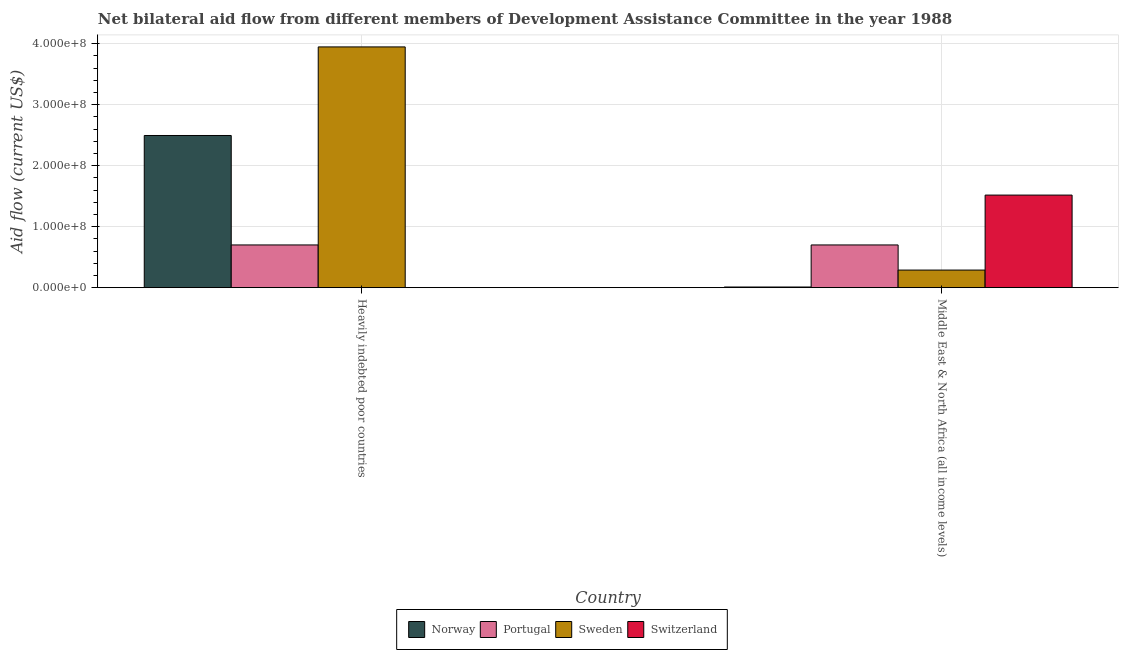Are the number of bars on each tick of the X-axis equal?
Your answer should be compact. Yes. How many bars are there on the 1st tick from the left?
Provide a short and direct response. 4. How many bars are there on the 1st tick from the right?
Give a very brief answer. 4. What is the label of the 1st group of bars from the left?
Your answer should be compact. Heavily indebted poor countries. In how many cases, is the number of bars for a given country not equal to the number of legend labels?
Your answer should be compact. 0. What is the amount of aid given by portugal in Heavily indebted poor countries?
Offer a terse response. 7.00e+07. Across all countries, what is the maximum amount of aid given by switzerland?
Provide a succinct answer. 1.52e+08. Across all countries, what is the minimum amount of aid given by switzerland?
Offer a terse response. 1.80e+05. In which country was the amount of aid given by norway maximum?
Ensure brevity in your answer.  Heavily indebted poor countries. In which country was the amount of aid given by sweden minimum?
Keep it short and to the point. Middle East & North Africa (all income levels). What is the total amount of aid given by norway in the graph?
Provide a succinct answer. 2.50e+08. What is the difference between the amount of aid given by norway in Heavily indebted poor countries and that in Middle East & North Africa (all income levels)?
Your response must be concise. 2.48e+08. What is the difference between the amount of aid given by norway in Heavily indebted poor countries and the amount of aid given by sweden in Middle East & North Africa (all income levels)?
Offer a terse response. 2.21e+08. What is the average amount of aid given by switzerland per country?
Make the answer very short. 7.60e+07. What is the difference between the amount of aid given by sweden and amount of aid given by switzerland in Heavily indebted poor countries?
Give a very brief answer. 3.94e+08. In how many countries, is the amount of aid given by norway greater than 20000000 US$?
Your answer should be very brief. 1. What is the ratio of the amount of aid given by sweden in Heavily indebted poor countries to that in Middle East & North Africa (all income levels)?
Provide a short and direct response. 13.68. Is the amount of aid given by sweden in Heavily indebted poor countries less than that in Middle East & North Africa (all income levels)?
Offer a very short reply. No. In how many countries, is the amount of aid given by switzerland greater than the average amount of aid given by switzerland taken over all countries?
Provide a succinct answer. 1. Is it the case that in every country, the sum of the amount of aid given by sweden and amount of aid given by portugal is greater than the sum of amount of aid given by norway and amount of aid given by switzerland?
Offer a very short reply. No. What does the 1st bar from the left in Heavily indebted poor countries represents?
Your response must be concise. Norway. What does the 3rd bar from the right in Heavily indebted poor countries represents?
Provide a succinct answer. Portugal. Is it the case that in every country, the sum of the amount of aid given by norway and amount of aid given by portugal is greater than the amount of aid given by sweden?
Offer a terse response. No. How many bars are there?
Ensure brevity in your answer.  8. What is the difference between two consecutive major ticks on the Y-axis?
Your response must be concise. 1.00e+08. Are the values on the major ticks of Y-axis written in scientific E-notation?
Your response must be concise. Yes. Does the graph contain grids?
Offer a terse response. Yes. Where does the legend appear in the graph?
Your response must be concise. Bottom center. What is the title of the graph?
Offer a very short reply. Net bilateral aid flow from different members of Development Assistance Committee in the year 1988. What is the Aid flow (current US$) in Norway in Heavily indebted poor countries?
Your answer should be very brief. 2.49e+08. What is the Aid flow (current US$) in Portugal in Heavily indebted poor countries?
Offer a very short reply. 7.00e+07. What is the Aid flow (current US$) in Sweden in Heavily indebted poor countries?
Your response must be concise. 3.95e+08. What is the Aid flow (current US$) in Switzerland in Heavily indebted poor countries?
Give a very brief answer. 1.80e+05. What is the Aid flow (current US$) in Norway in Middle East & North Africa (all income levels)?
Your response must be concise. 1.07e+06. What is the Aid flow (current US$) of Portugal in Middle East & North Africa (all income levels)?
Make the answer very short. 7.00e+07. What is the Aid flow (current US$) in Sweden in Middle East & North Africa (all income levels)?
Provide a short and direct response. 2.88e+07. What is the Aid flow (current US$) in Switzerland in Middle East & North Africa (all income levels)?
Offer a terse response. 1.52e+08. Across all countries, what is the maximum Aid flow (current US$) in Norway?
Make the answer very short. 2.49e+08. Across all countries, what is the maximum Aid flow (current US$) in Portugal?
Your answer should be compact. 7.00e+07. Across all countries, what is the maximum Aid flow (current US$) of Sweden?
Your answer should be compact. 3.95e+08. Across all countries, what is the maximum Aid flow (current US$) of Switzerland?
Give a very brief answer. 1.52e+08. Across all countries, what is the minimum Aid flow (current US$) of Norway?
Offer a terse response. 1.07e+06. Across all countries, what is the minimum Aid flow (current US$) of Portugal?
Your answer should be very brief. 7.00e+07. Across all countries, what is the minimum Aid flow (current US$) of Sweden?
Provide a succinct answer. 2.88e+07. Across all countries, what is the minimum Aid flow (current US$) in Switzerland?
Your answer should be very brief. 1.80e+05. What is the total Aid flow (current US$) of Norway in the graph?
Your answer should be very brief. 2.50e+08. What is the total Aid flow (current US$) in Portugal in the graph?
Ensure brevity in your answer.  1.40e+08. What is the total Aid flow (current US$) in Sweden in the graph?
Your response must be concise. 4.23e+08. What is the total Aid flow (current US$) of Switzerland in the graph?
Offer a very short reply. 1.52e+08. What is the difference between the Aid flow (current US$) of Norway in Heavily indebted poor countries and that in Middle East & North Africa (all income levels)?
Keep it short and to the point. 2.48e+08. What is the difference between the Aid flow (current US$) of Sweden in Heavily indebted poor countries and that in Middle East & North Africa (all income levels)?
Make the answer very short. 3.66e+08. What is the difference between the Aid flow (current US$) in Switzerland in Heavily indebted poor countries and that in Middle East & North Africa (all income levels)?
Offer a very short reply. -1.52e+08. What is the difference between the Aid flow (current US$) in Norway in Heavily indebted poor countries and the Aid flow (current US$) in Portugal in Middle East & North Africa (all income levels)?
Your answer should be compact. 1.79e+08. What is the difference between the Aid flow (current US$) of Norway in Heavily indebted poor countries and the Aid flow (current US$) of Sweden in Middle East & North Africa (all income levels)?
Ensure brevity in your answer.  2.21e+08. What is the difference between the Aid flow (current US$) of Norway in Heavily indebted poor countries and the Aid flow (current US$) of Switzerland in Middle East & North Africa (all income levels)?
Give a very brief answer. 9.77e+07. What is the difference between the Aid flow (current US$) in Portugal in Heavily indebted poor countries and the Aid flow (current US$) in Sweden in Middle East & North Africa (all income levels)?
Your answer should be compact. 4.12e+07. What is the difference between the Aid flow (current US$) in Portugal in Heavily indebted poor countries and the Aid flow (current US$) in Switzerland in Middle East & North Africa (all income levels)?
Provide a succinct answer. -8.17e+07. What is the difference between the Aid flow (current US$) of Sweden in Heavily indebted poor countries and the Aid flow (current US$) of Switzerland in Middle East & North Africa (all income levels)?
Provide a succinct answer. 2.43e+08. What is the average Aid flow (current US$) in Norway per country?
Your answer should be very brief. 1.25e+08. What is the average Aid flow (current US$) of Portugal per country?
Keep it short and to the point. 7.00e+07. What is the average Aid flow (current US$) in Sweden per country?
Keep it short and to the point. 2.12e+08. What is the average Aid flow (current US$) in Switzerland per country?
Your response must be concise. 7.60e+07. What is the difference between the Aid flow (current US$) in Norway and Aid flow (current US$) in Portugal in Heavily indebted poor countries?
Provide a succinct answer. 1.79e+08. What is the difference between the Aid flow (current US$) in Norway and Aid flow (current US$) in Sweden in Heavily indebted poor countries?
Your answer should be compact. -1.45e+08. What is the difference between the Aid flow (current US$) of Norway and Aid flow (current US$) of Switzerland in Heavily indebted poor countries?
Provide a succinct answer. 2.49e+08. What is the difference between the Aid flow (current US$) in Portugal and Aid flow (current US$) in Sweden in Heavily indebted poor countries?
Your answer should be compact. -3.25e+08. What is the difference between the Aid flow (current US$) of Portugal and Aid flow (current US$) of Switzerland in Heavily indebted poor countries?
Give a very brief answer. 6.98e+07. What is the difference between the Aid flow (current US$) in Sweden and Aid flow (current US$) in Switzerland in Heavily indebted poor countries?
Your answer should be compact. 3.94e+08. What is the difference between the Aid flow (current US$) of Norway and Aid flow (current US$) of Portugal in Middle East & North Africa (all income levels)?
Your answer should be compact. -6.89e+07. What is the difference between the Aid flow (current US$) of Norway and Aid flow (current US$) of Sweden in Middle East & North Africa (all income levels)?
Your answer should be compact. -2.78e+07. What is the difference between the Aid flow (current US$) in Norway and Aid flow (current US$) in Switzerland in Middle East & North Africa (all income levels)?
Keep it short and to the point. -1.51e+08. What is the difference between the Aid flow (current US$) of Portugal and Aid flow (current US$) of Sweden in Middle East & North Africa (all income levels)?
Offer a terse response. 4.12e+07. What is the difference between the Aid flow (current US$) in Portugal and Aid flow (current US$) in Switzerland in Middle East & North Africa (all income levels)?
Keep it short and to the point. -8.17e+07. What is the difference between the Aid flow (current US$) in Sweden and Aid flow (current US$) in Switzerland in Middle East & North Africa (all income levels)?
Provide a succinct answer. -1.23e+08. What is the ratio of the Aid flow (current US$) of Norway in Heavily indebted poor countries to that in Middle East & North Africa (all income levels)?
Keep it short and to the point. 233.07. What is the ratio of the Aid flow (current US$) of Portugal in Heavily indebted poor countries to that in Middle East & North Africa (all income levels)?
Make the answer very short. 1. What is the ratio of the Aid flow (current US$) in Sweden in Heavily indebted poor countries to that in Middle East & North Africa (all income levels)?
Provide a succinct answer. 13.68. What is the ratio of the Aid flow (current US$) in Switzerland in Heavily indebted poor countries to that in Middle East & North Africa (all income levels)?
Your response must be concise. 0. What is the difference between the highest and the second highest Aid flow (current US$) in Norway?
Your response must be concise. 2.48e+08. What is the difference between the highest and the second highest Aid flow (current US$) in Portugal?
Offer a very short reply. 0. What is the difference between the highest and the second highest Aid flow (current US$) in Sweden?
Your response must be concise. 3.66e+08. What is the difference between the highest and the second highest Aid flow (current US$) of Switzerland?
Give a very brief answer. 1.52e+08. What is the difference between the highest and the lowest Aid flow (current US$) of Norway?
Offer a very short reply. 2.48e+08. What is the difference between the highest and the lowest Aid flow (current US$) of Sweden?
Make the answer very short. 3.66e+08. What is the difference between the highest and the lowest Aid flow (current US$) of Switzerland?
Offer a very short reply. 1.52e+08. 